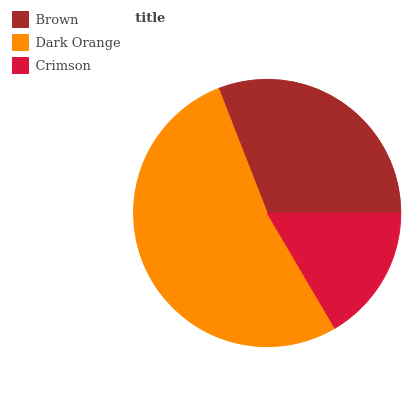Is Crimson the minimum?
Answer yes or no. Yes. Is Dark Orange the maximum?
Answer yes or no. Yes. Is Dark Orange the minimum?
Answer yes or no. No. Is Crimson the maximum?
Answer yes or no. No. Is Dark Orange greater than Crimson?
Answer yes or no. Yes. Is Crimson less than Dark Orange?
Answer yes or no. Yes. Is Crimson greater than Dark Orange?
Answer yes or no. No. Is Dark Orange less than Crimson?
Answer yes or no. No. Is Brown the high median?
Answer yes or no. Yes. Is Brown the low median?
Answer yes or no. Yes. Is Dark Orange the high median?
Answer yes or no. No. Is Dark Orange the low median?
Answer yes or no. No. 